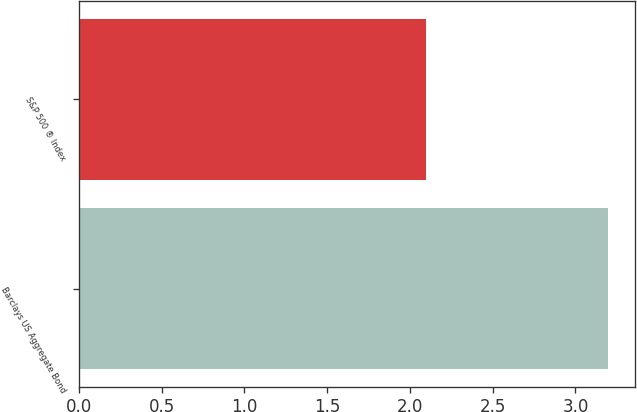<chart> <loc_0><loc_0><loc_500><loc_500><bar_chart><fcel>Barclays US Aggregate Bond<fcel>S&P 500 ® Index<nl><fcel>3.2<fcel>2.1<nl></chart> 